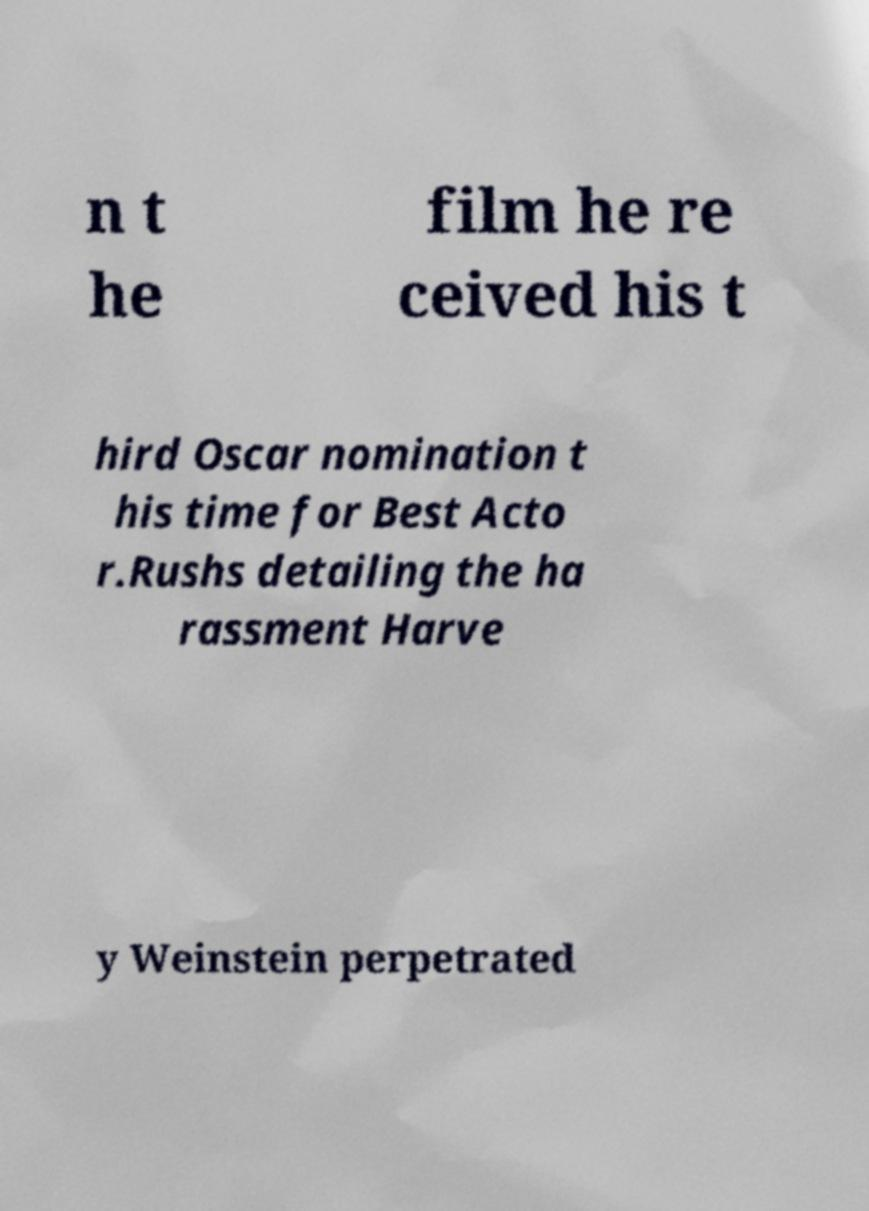I need the written content from this picture converted into text. Can you do that? n t he film he re ceived his t hird Oscar nomination t his time for Best Acto r.Rushs detailing the ha rassment Harve y Weinstein perpetrated 